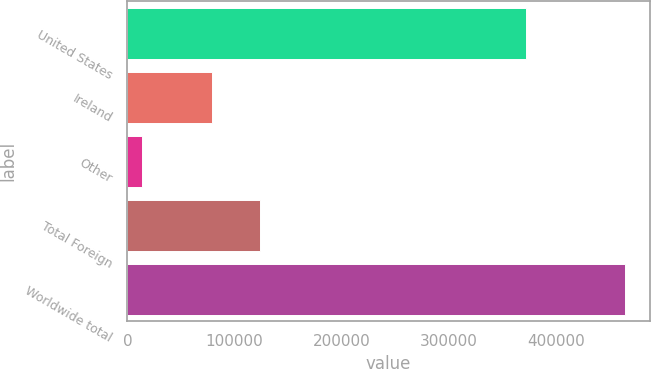Convert chart to OTSL. <chart><loc_0><loc_0><loc_500><loc_500><bar_chart><fcel>United States<fcel>Ireland<fcel>Other<fcel>Total Foreign<fcel>Worldwide total<nl><fcel>371380<fcel>78908<fcel>13643<fcel>123937<fcel>463931<nl></chart> 